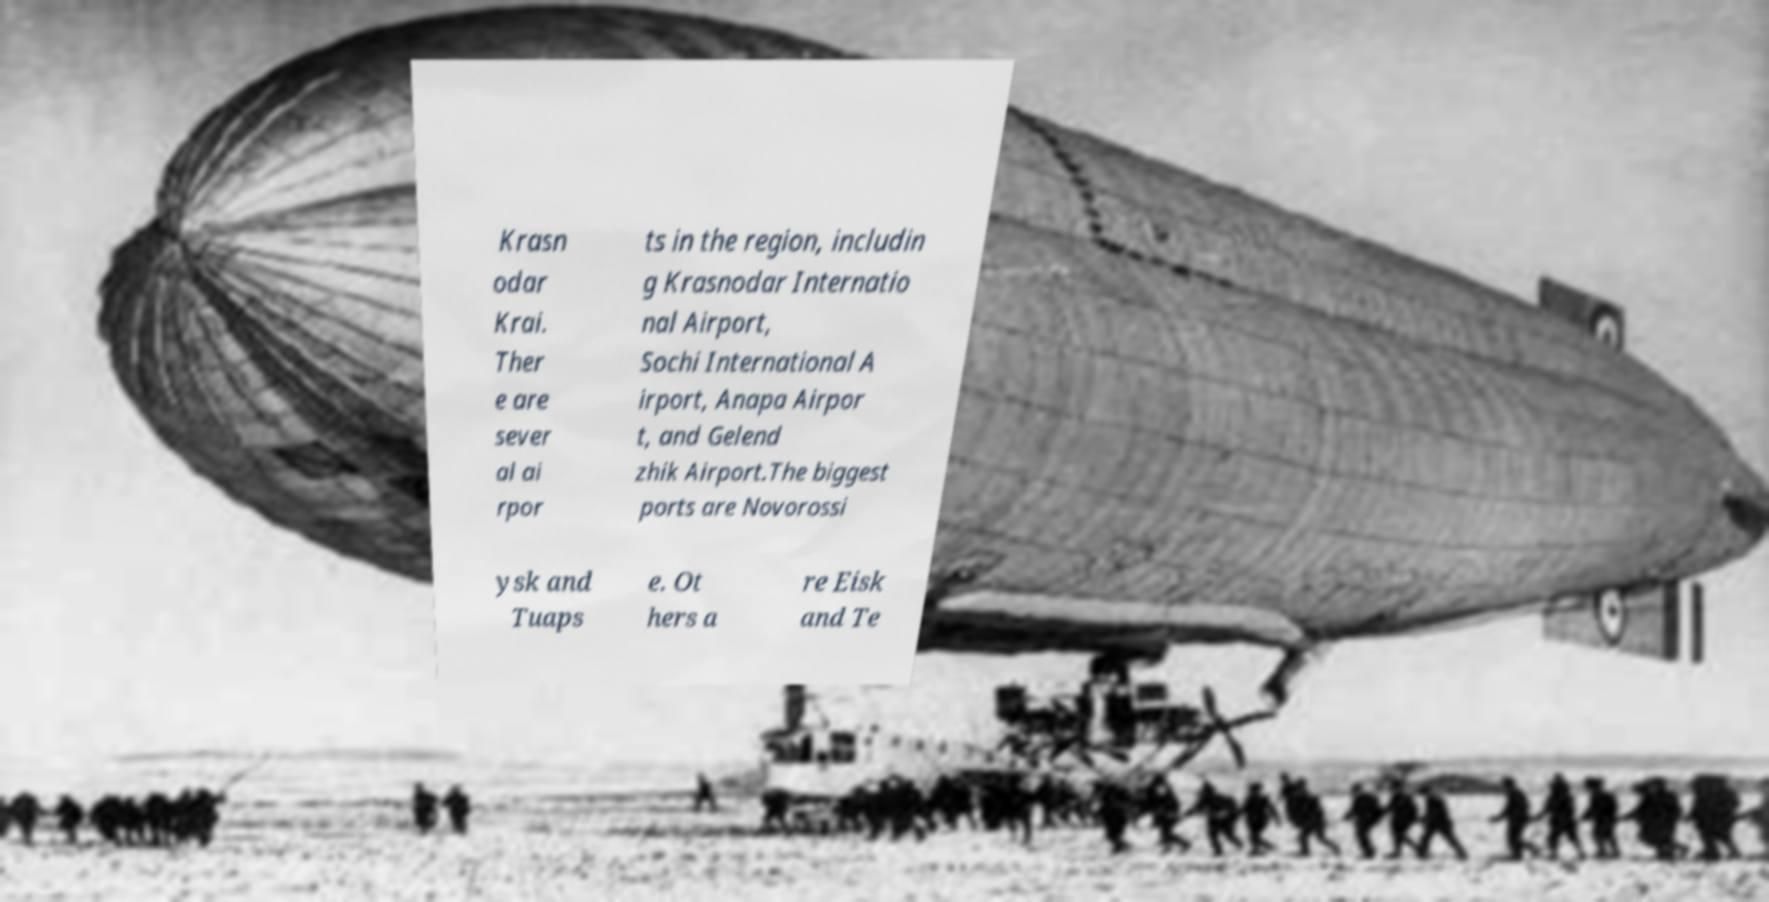Could you assist in decoding the text presented in this image and type it out clearly? Krasn odar Krai. Ther e are sever al ai rpor ts in the region, includin g Krasnodar Internatio nal Airport, Sochi International A irport, Anapa Airpor t, and Gelend zhik Airport.The biggest ports are Novorossi ysk and Tuaps e. Ot hers a re Eisk and Te 